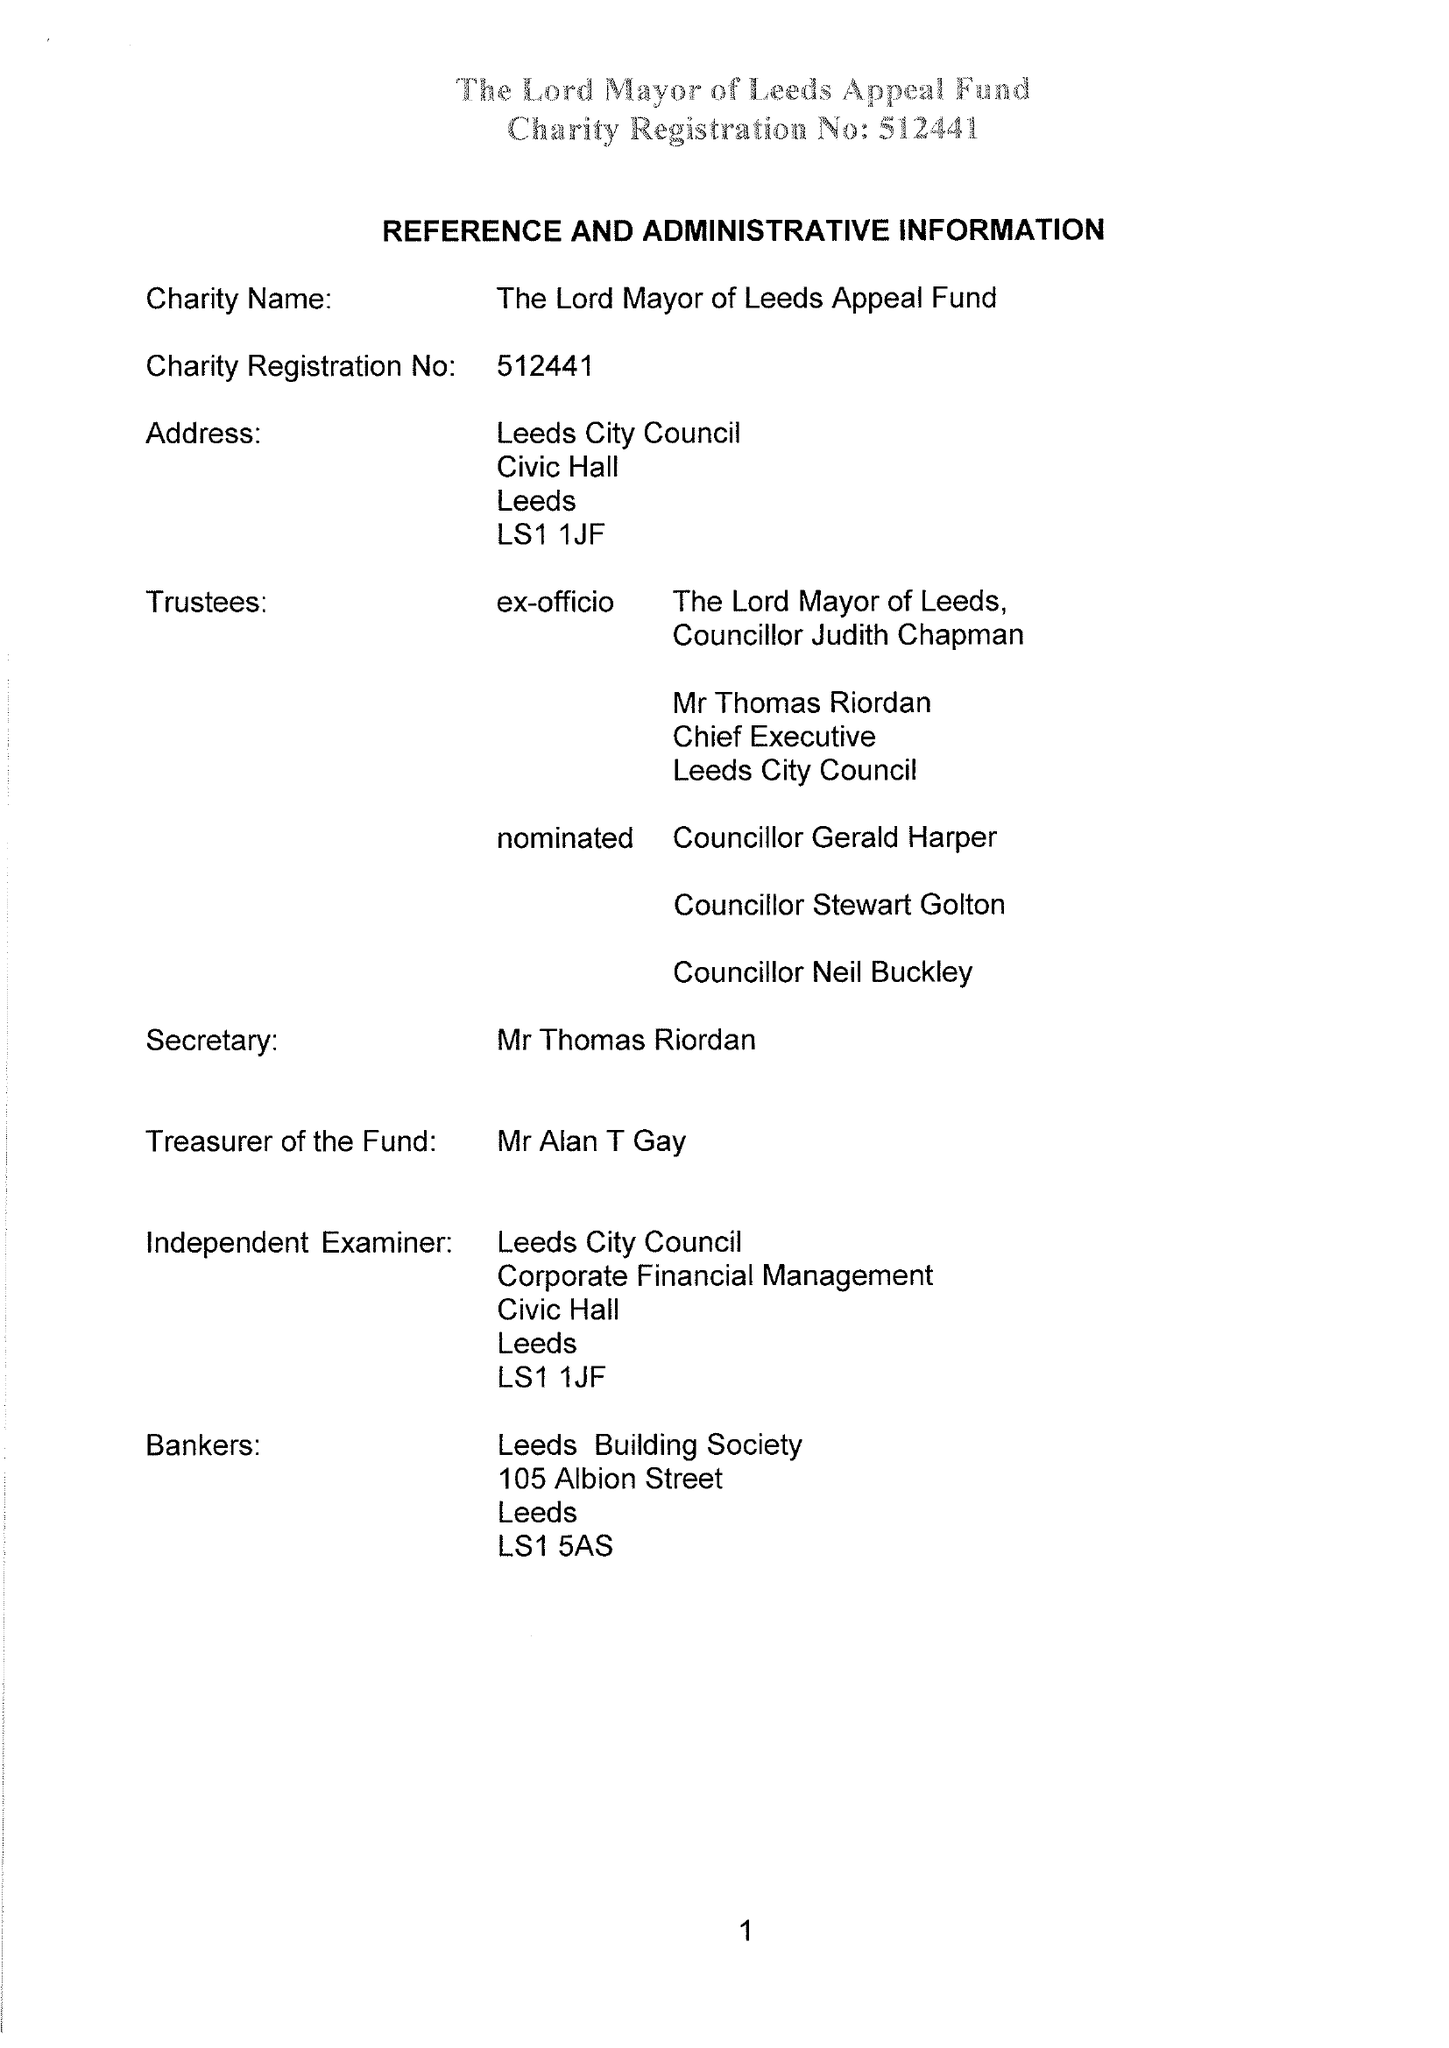What is the value for the spending_annually_in_british_pounds?
Answer the question using a single word or phrase. 36486.00 